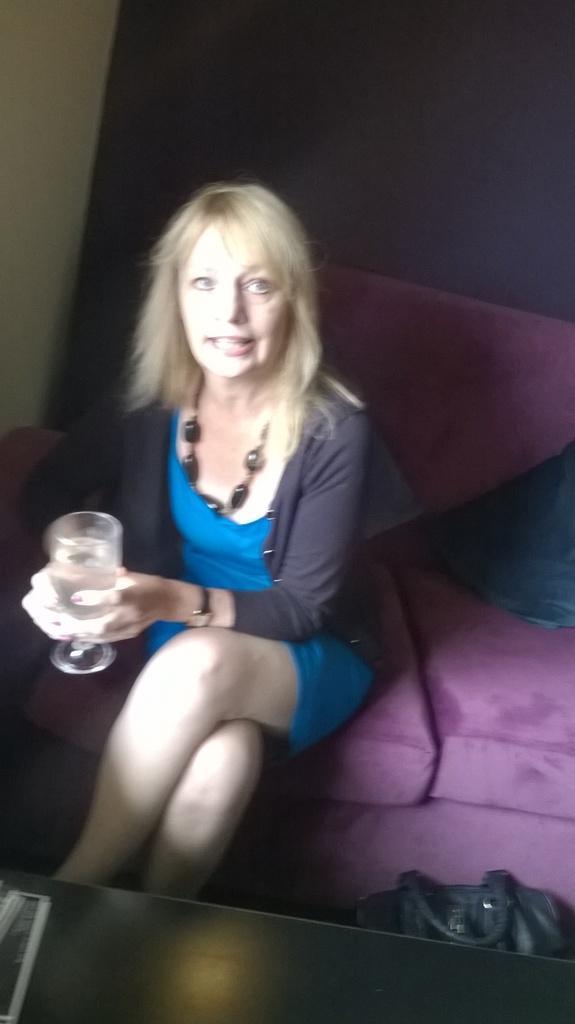In one or two sentences, can you explain what this image depicts? This picture is taken inside the room. Woman in blue and black dress is sitting on sofa. She is wearing watch on her hands and she is holding a glass containing some liquid in her hands. I think she is talking. Behind her, we see a sheet which is dark blue in color and beside her, we see a black bag. In front of her, we see table. 